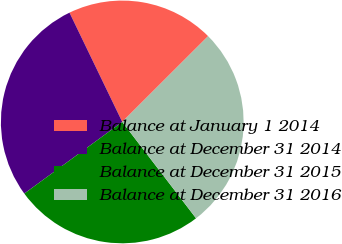<chart> <loc_0><loc_0><loc_500><loc_500><pie_chart><fcel>Balance at January 1 2014<fcel>Balance at December 31 2014<fcel>Balance at December 31 2015<fcel>Balance at December 31 2016<nl><fcel>19.67%<fcel>27.89%<fcel>25.35%<fcel>27.09%<nl></chart> 